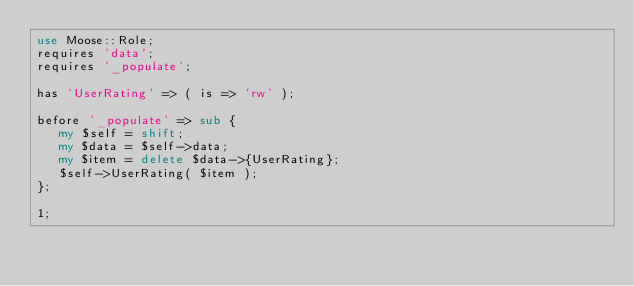<code> <loc_0><loc_0><loc_500><loc_500><_Perl_>use Moose::Role;
requires 'data';
requires '_populate';

has 'UserRating' => ( is => 'rw' );

before '_populate' => sub { 
   my $self = shift;
   my $data = $self->data;
   my $item = delete $data->{UserRating};
   $self->UserRating( $item );
};

1;
</code> 